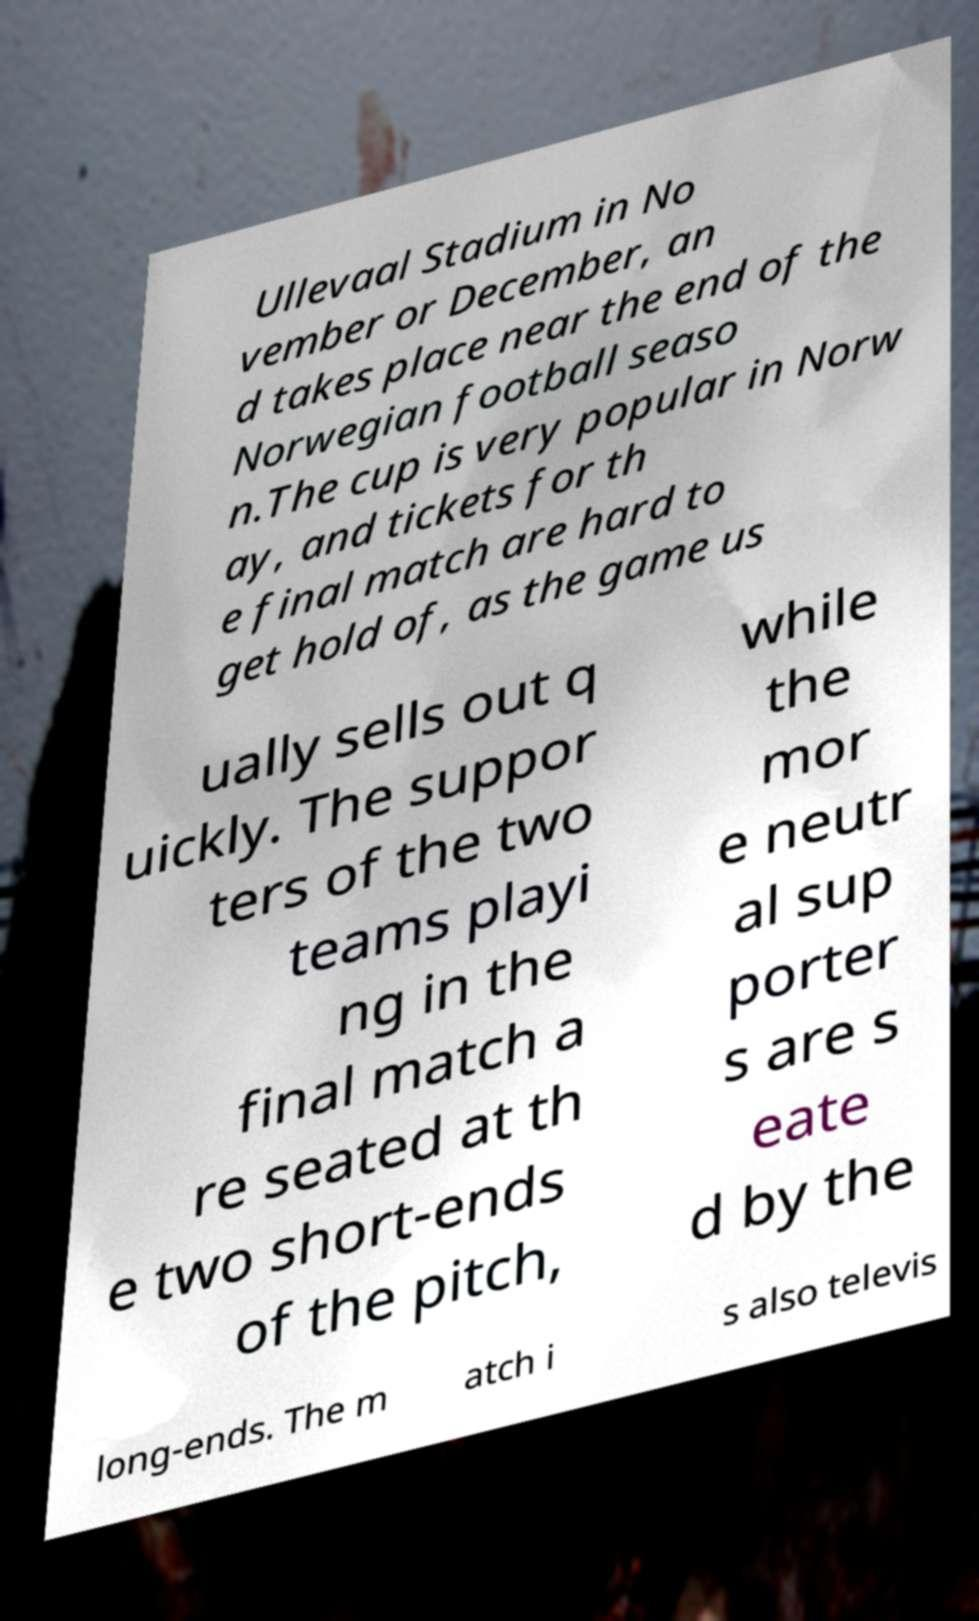Could you assist in decoding the text presented in this image and type it out clearly? Ullevaal Stadium in No vember or December, an d takes place near the end of the Norwegian football seaso n.The cup is very popular in Norw ay, and tickets for th e final match are hard to get hold of, as the game us ually sells out q uickly. The suppor ters of the two teams playi ng in the final match a re seated at th e two short-ends of the pitch, while the mor e neutr al sup porter s are s eate d by the long-ends. The m atch i s also televis 